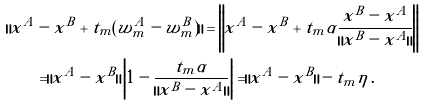Convert formula to latex. <formula><loc_0><loc_0><loc_500><loc_500>\| x ^ { A } & - x ^ { B } + t _ { m } ( w ^ { A } _ { m } - w ^ { B } _ { m } ) \| = \left \| x ^ { A } - x ^ { B } + t _ { m } \alpha \frac { x ^ { B } - x ^ { A } } { \| x ^ { B } - x ^ { A } \| } \right \| \\ & = \| x ^ { A } - x ^ { B } \| \left | 1 - \frac { t _ { m } \alpha } { \| x ^ { B } - x ^ { A } \| } \right | = \| x ^ { A } - x ^ { B } \| - t _ { m } \eta \, .</formula> 